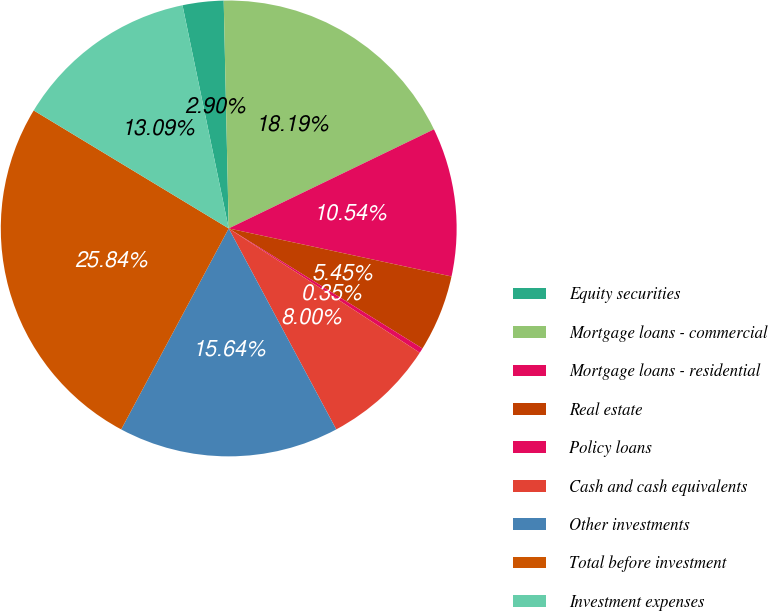Convert chart. <chart><loc_0><loc_0><loc_500><loc_500><pie_chart><fcel>Equity securities<fcel>Mortgage loans - commercial<fcel>Mortgage loans - residential<fcel>Real estate<fcel>Policy loans<fcel>Cash and cash equivalents<fcel>Other investments<fcel>Total before investment<fcel>Investment expenses<nl><fcel>2.9%<fcel>18.19%<fcel>10.54%<fcel>5.45%<fcel>0.35%<fcel>8.0%<fcel>15.64%<fcel>25.84%<fcel>13.09%<nl></chart> 